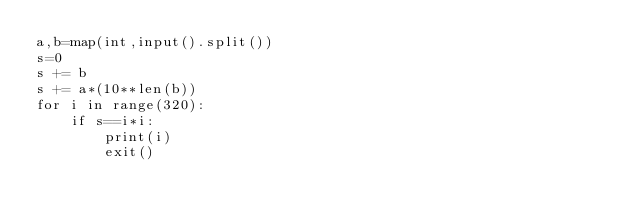Convert code to text. <code><loc_0><loc_0><loc_500><loc_500><_Python_>a,b=map(int,input().split())
s=0
s += b
s += a*(10**len(b))
for i in range(320):
    if s==i*i:
        print(i)
        exit()
</code> 